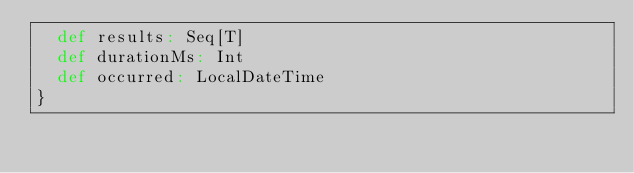<code> <loc_0><loc_0><loc_500><loc_500><_Scala_>  def results: Seq[T]
  def durationMs: Int
  def occurred: LocalDateTime
}
</code> 